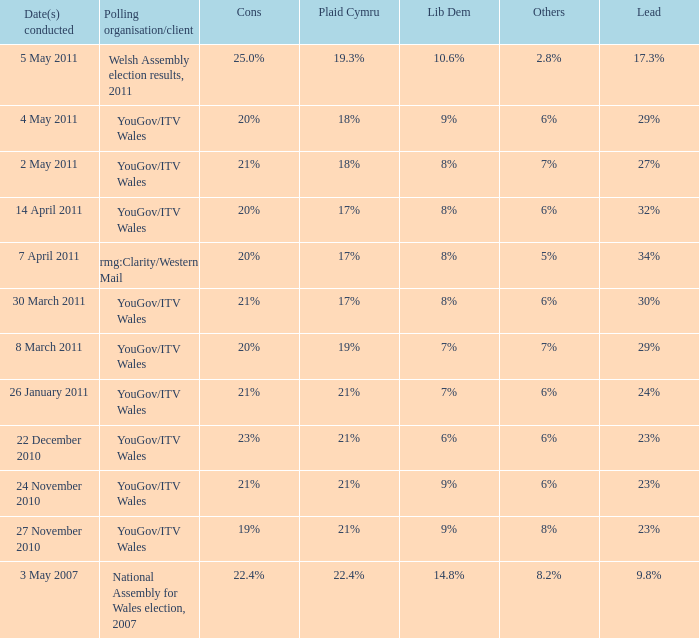I seek the forefront for others at 5%. 34%. 